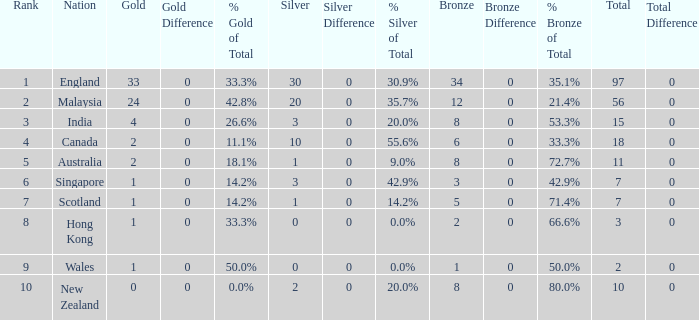What is the highest rank a team with 1 silver and less than 5 bronze medals has? None. 